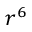<formula> <loc_0><loc_0><loc_500><loc_500>r ^ { 6 }</formula> 